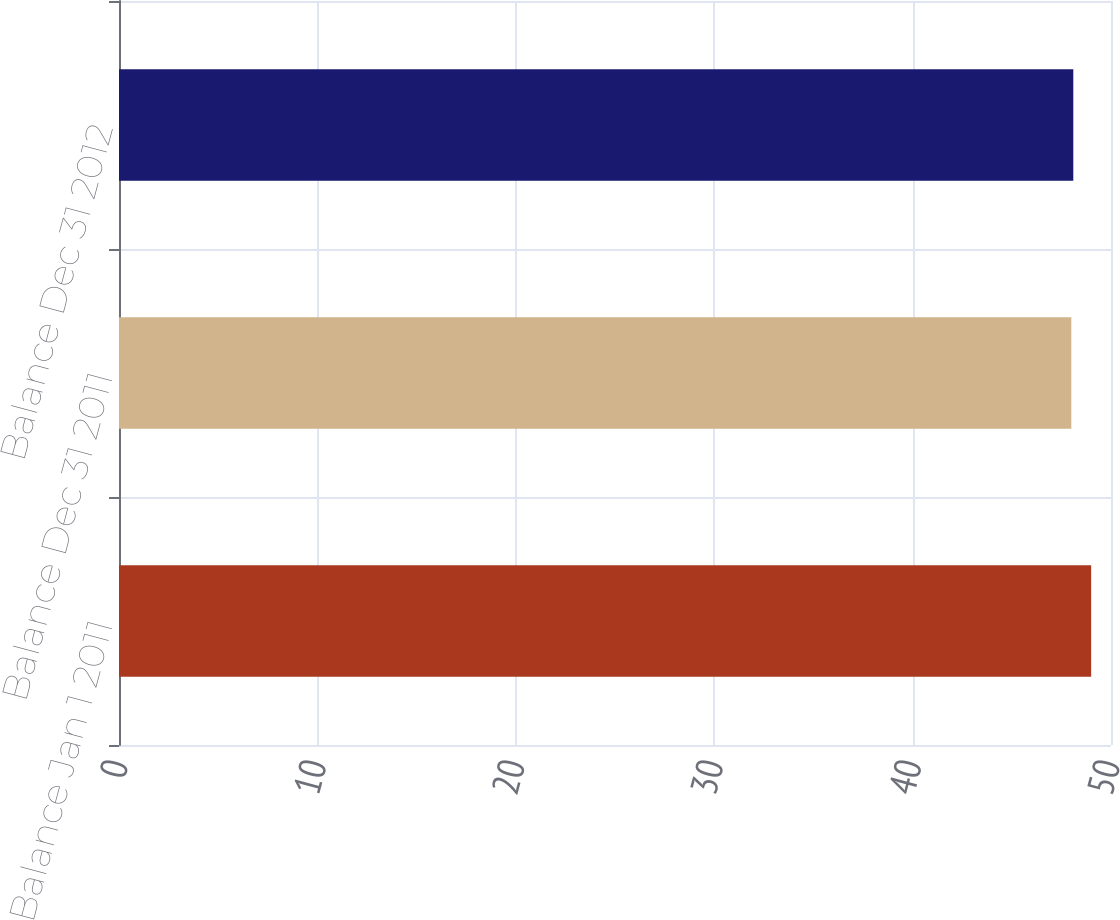Convert chart. <chart><loc_0><loc_0><loc_500><loc_500><bar_chart><fcel>Balance Jan 1 2011<fcel>Balance Dec 31 2011<fcel>Balance Dec 31 2012<nl><fcel>49<fcel>48<fcel>48.1<nl></chart> 